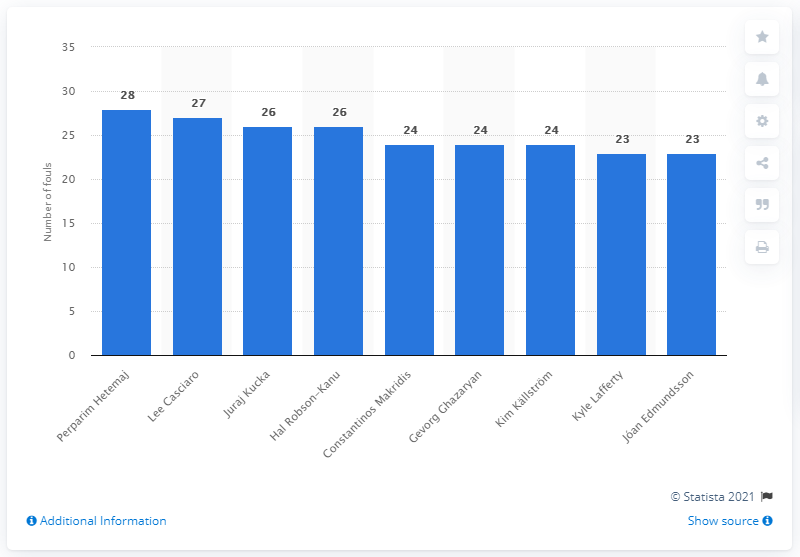Point out several critical features in this image. During the qualifying phase of the European Championship 2016, Perparim Hetemaj committed 28 fouls. Perparim Hetemaj committed the most fouls during the qualifying phase of the European Championship 2016. 